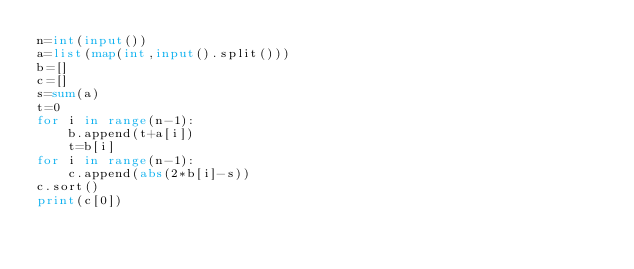<code> <loc_0><loc_0><loc_500><loc_500><_Python_>n=int(input())
a=list(map(int,input().split()))
b=[]
c=[]
s=sum(a)
t=0
for i in range(n-1):
    b.append(t+a[i])
    t=b[i]
for i in range(n-1):
    c.append(abs(2*b[i]-s))
c.sort()
print(c[0])</code> 